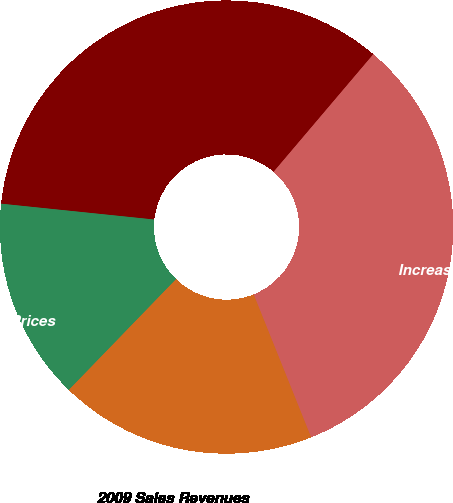Convert chart to OTSL. <chart><loc_0><loc_0><loc_500><loc_500><pie_chart><fcel>Increase (Decrease) in Sales<fcel>2008 Sales Revenues<fcel>Decrease in Sales Prices<fcel>2009 Sales Revenues<nl><fcel>32.72%<fcel>34.55%<fcel>14.4%<fcel>18.32%<nl></chart> 